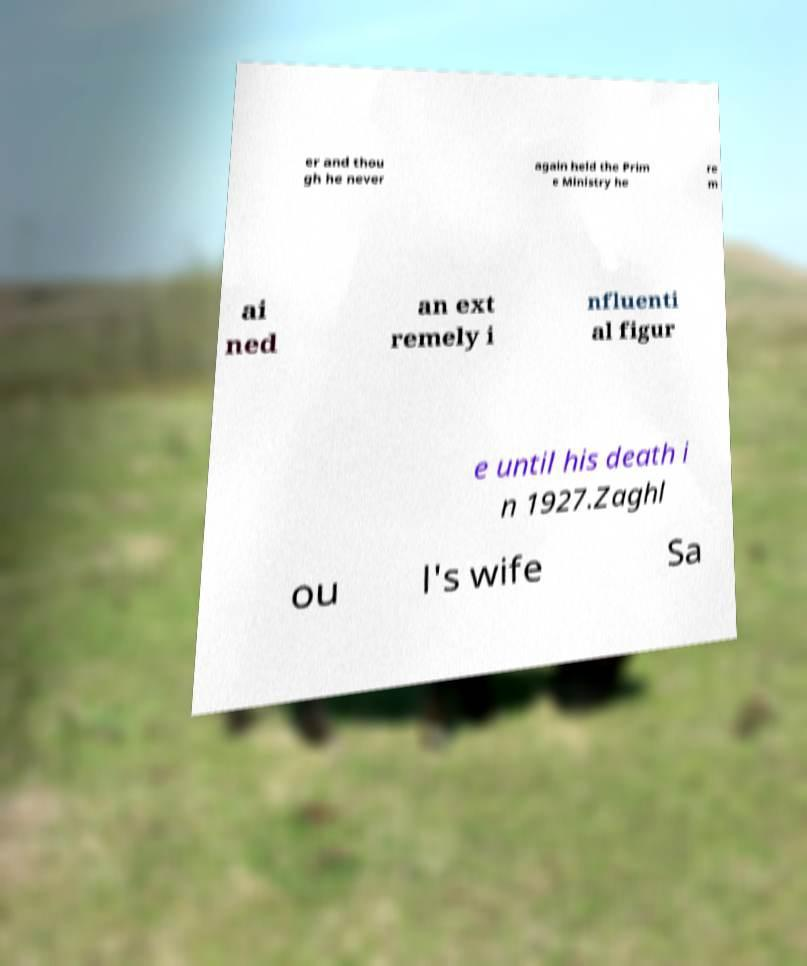Can you read and provide the text displayed in the image?This photo seems to have some interesting text. Can you extract and type it out for me? er and thou gh he never again held the Prim e Ministry he re m ai ned an ext remely i nfluenti al figur e until his death i n 1927.Zaghl ou l's wife Sa 